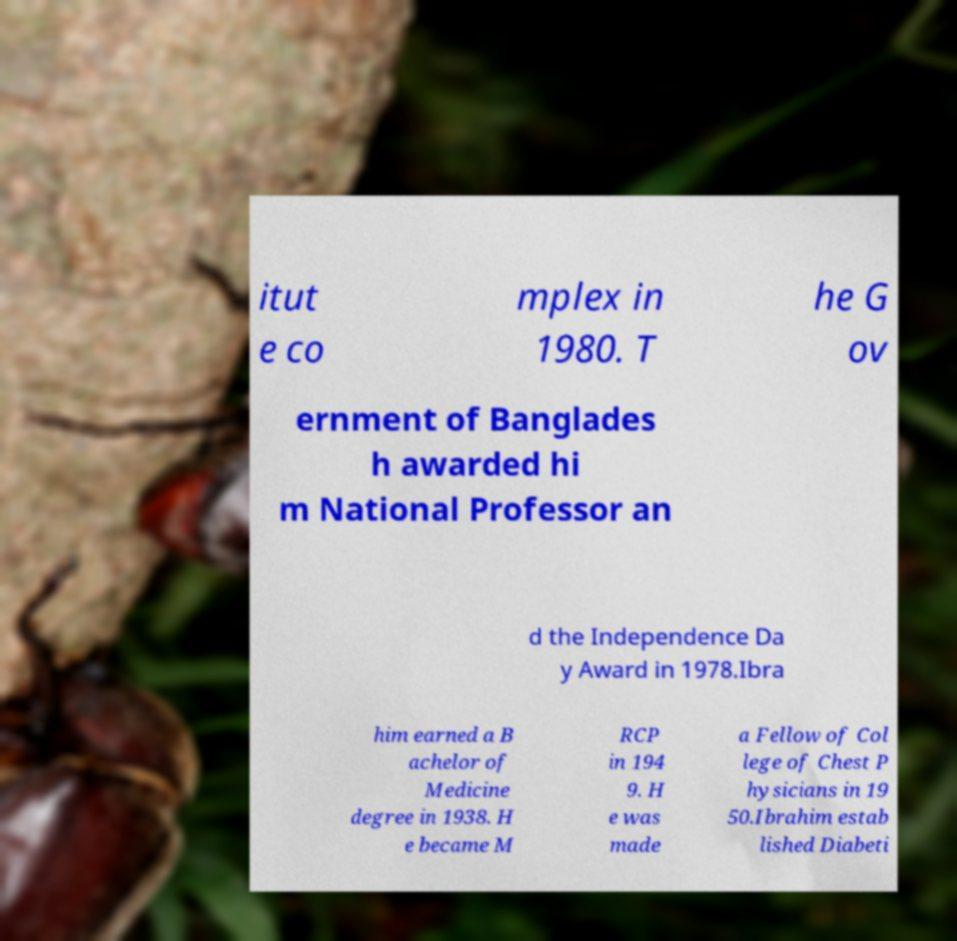There's text embedded in this image that I need extracted. Can you transcribe it verbatim? itut e co mplex in 1980. T he G ov ernment of Banglades h awarded hi m National Professor an d the Independence Da y Award in 1978.Ibra him earned a B achelor of Medicine degree in 1938. H e became M RCP in 194 9. H e was made a Fellow of Col lege of Chest P hysicians in 19 50.Ibrahim estab lished Diabeti 